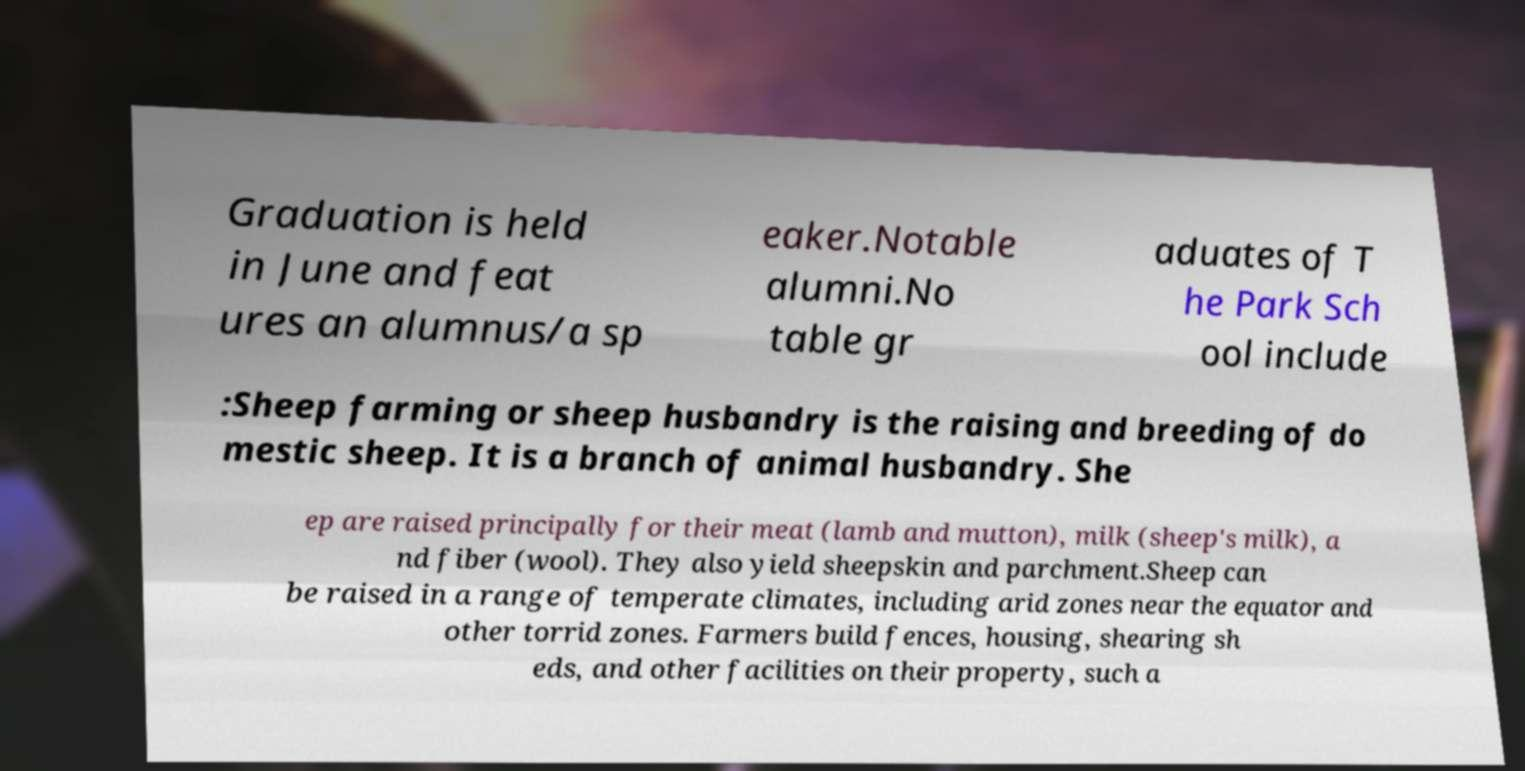What messages or text are displayed in this image? I need them in a readable, typed format. Graduation is held in June and feat ures an alumnus/a sp eaker.Notable alumni.No table gr aduates of T he Park Sch ool include :Sheep farming or sheep husbandry is the raising and breeding of do mestic sheep. It is a branch of animal husbandry. She ep are raised principally for their meat (lamb and mutton), milk (sheep's milk), a nd fiber (wool). They also yield sheepskin and parchment.Sheep can be raised in a range of temperate climates, including arid zones near the equator and other torrid zones. Farmers build fences, housing, shearing sh eds, and other facilities on their property, such a 